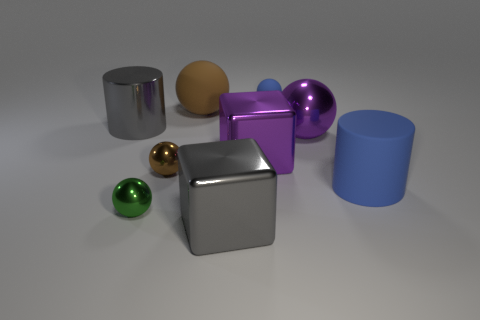Subtract all small matte spheres. How many spheres are left? 4 Subtract all gray cubes. How many cubes are left? 1 Subtract 1 blocks. How many blocks are left? 1 Add 1 small red shiny cylinders. How many objects exist? 10 Subtract all blocks. How many objects are left? 7 Subtract all green balls. How many gray cubes are left? 1 Subtract all brown rubber balls. Subtract all blue matte cylinders. How many objects are left? 7 Add 6 large purple blocks. How many large purple blocks are left? 7 Add 5 gray cylinders. How many gray cylinders exist? 6 Subtract 1 green spheres. How many objects are left? 8 